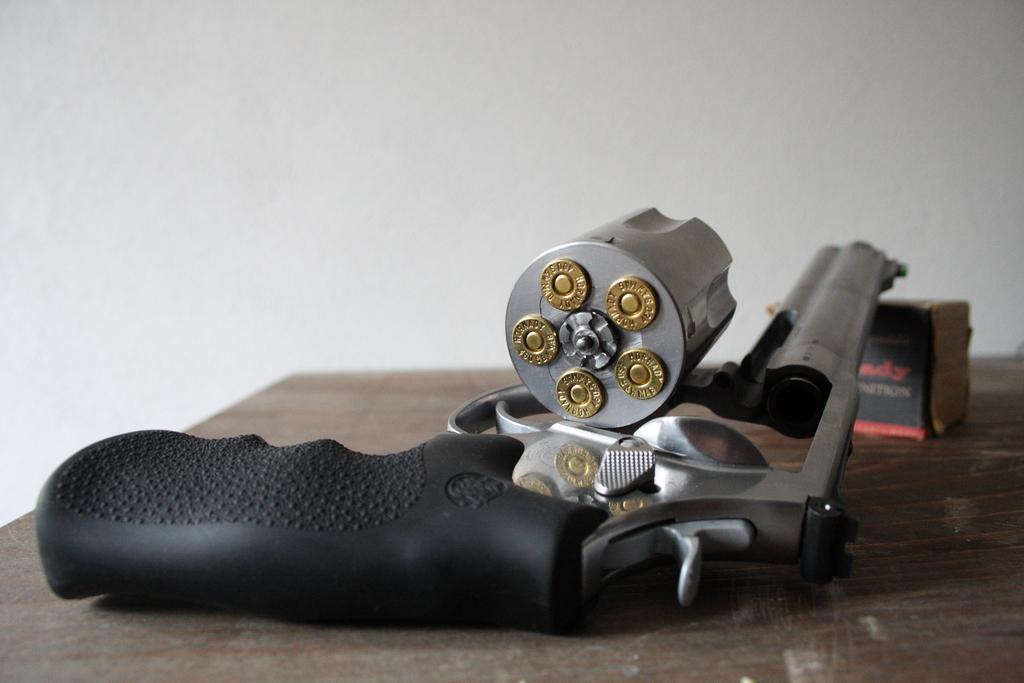Could you give a brief overview of what you see in this image? In this image, we can see a gun with bullets and there is a box, which are placed on the table. In the background, there is a wall. 